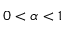Convert formula to latex. <formula><loc_0><loc_0><loc_500><loc_500>0 < \alpha < 1</formula> 